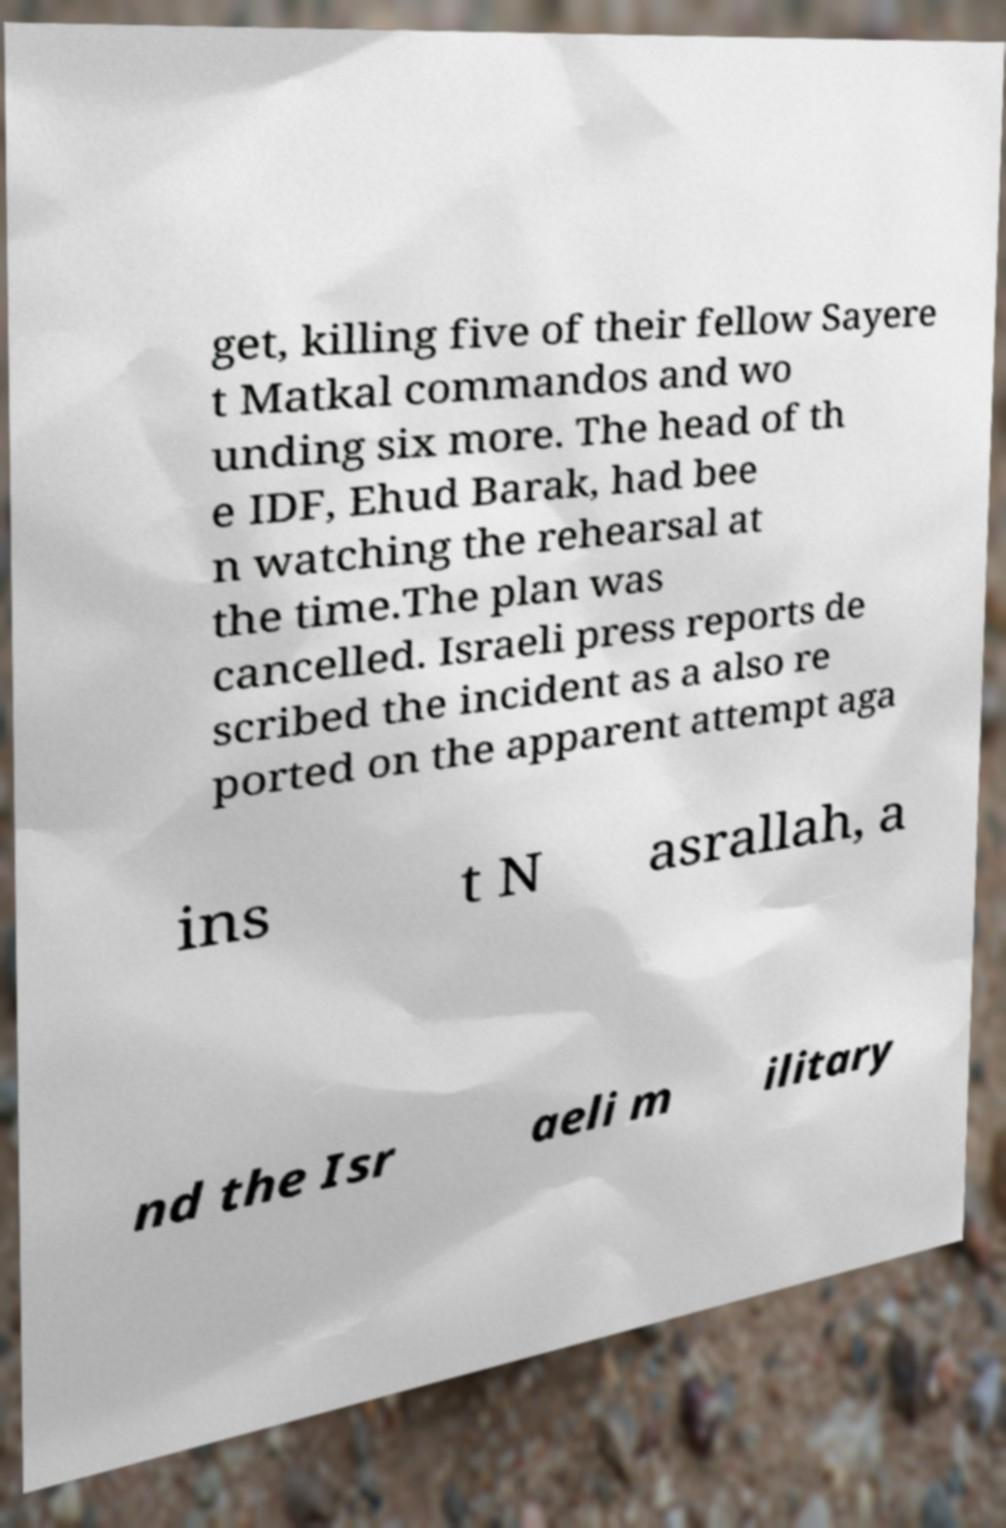Can you accurately transcribe the text from the provided image for me? get, killing five of their fellow Sayere t Matkal commandos and wo unding six more. The head of th e IDF, Ehud Barak, had bee n watching the rehearsal at the time.The plan was cancelled. Israeli press reports de scribed the incident as a also re ported on the apparent attempt aga ins t N asrallah, a nd the Isr aeli m ilitary 